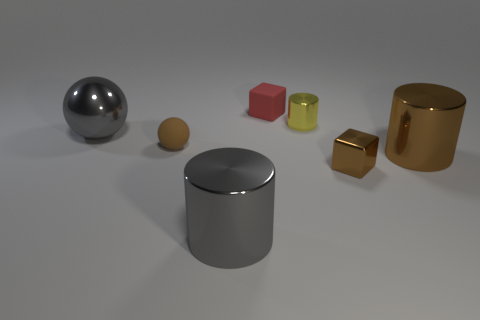Subtract all big brown metallic cylinders. How many cylinders are left? 2 Add 3 brown matte spheres. How many objects exist? 10 Subtract all red blocks. How many blocks are left? 1 Subtract 1 cylinders. How many cylinders are left? 2 Add 7 blocks. How many blocks are left? 9 Add 1 tiny shiny cubes. How many tiny shiny cubes exist? 2 Subtract 0 cyan cubes. How many objects are left? 7 Subtract all balls. How many objects are left? 5 Subtract all cyan cylinders. Subtract all cyan blocks. How many cylinders are left? 3 Subtract all green matte spheres. Subtract all small brown matte balls. How many objects are left? 6 